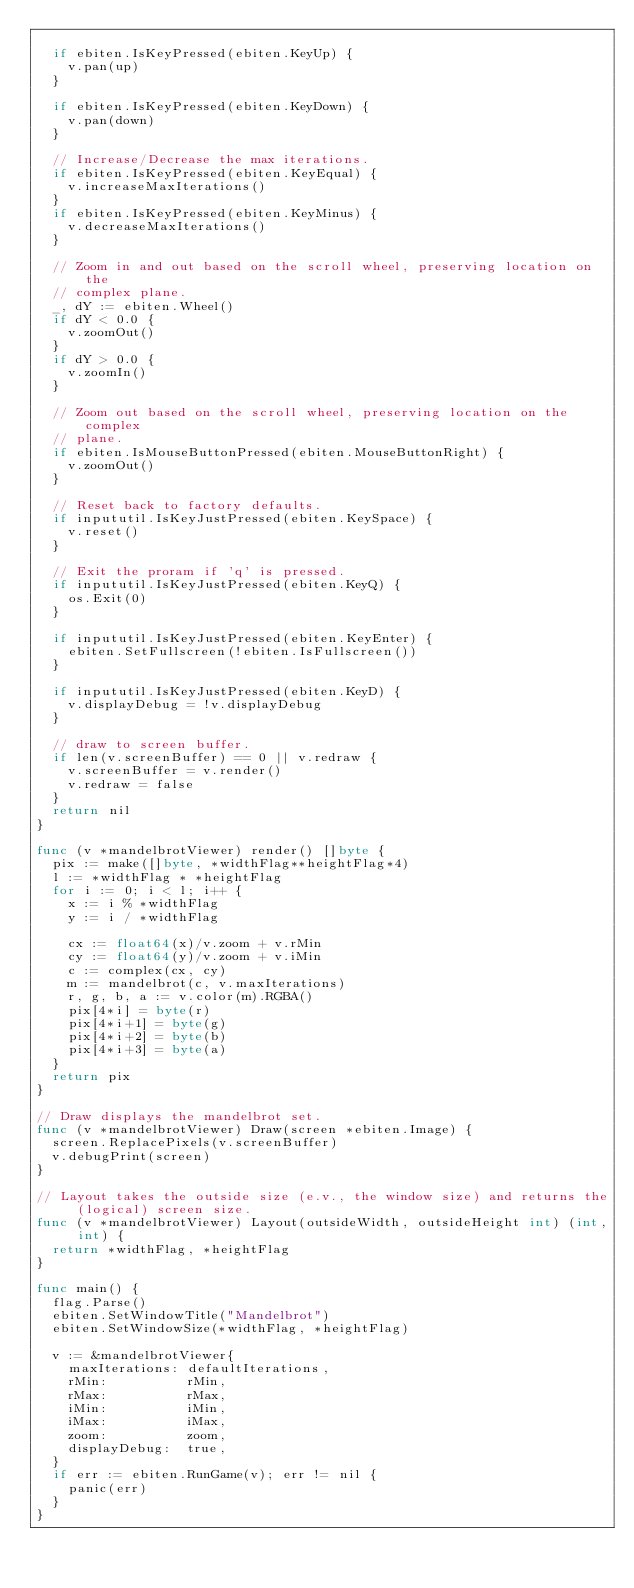Convert code to text. <code><loc_0><loc_0><loc_500><loc_500><_Go_>
	if ebiten.IsKeyPressed(ebiten.KeyUp) {
		v.pan(up)
	}

	if ebiten.IsKeyPressed(ebiten.KeyDown) {
		v.pan(down)
	}

	// Increase/Decrease the max iterations.
	if ebiten.IsKeyPressed(ebiten.KeyEqual) {
		v.increaseMaxIterations()
	}
	if ebiten.IsKeyPressed(ebiten.KeyMinus) {
		v.decreaseMaxIterations()
	}

	// Zoom in and out based on the scroll wheel, preserving location on the
	// complex plane.
	_, dY := ebiten.Wheel()
	if dY < 0.0 {
		v.zoomOut()
	}
	if dY > 0.0 {
		v.zoomIn()
	}

	// Zoom out based on the scroll wheel, preserving location on the complex
	// plane.
	if ebiten.IsMouseButtonPressed(ebiten.MouseButtonRight) {
		v.zoomOut()
	}

	// Reset back to factory defaults.
	if inpututil.IsKeyJustPressed(ebiten.KeySpace) {
		v.reset()
	}

	// Exit the proram if 'q' is pressed.
	if inpututil.IsKeyJustPressed(ebiten.KeyQ) {
		os.Exit(0)
	}

	if inpututil.IsKeyJustPressed(ebiten.KeyEnter) {
		ebiten.SetFullscreen(!ebiten.IsFullscreen())
	}

	if inpututil.IsKeyJustPressed(ebiten.KeyD) {
		v.displayDebug = !v.displayDebug
	}

	// draw to screen buffer.
	if len(v.screenBuffer) == 0 || v.redraw {
		v.screenBuffer = v.render()
		v.redraw = false
	}
	return nil
}

func (v *mandelbrotViewer) render() []byte {
	pix := make([]byte, *widthFlag**heightFlag*4)
	l := *widthFlag * *heightFlag
	for i := 0; i < l; i++ {
		x := i % *widthFlag
		y := i / *widthFlag

		cx := float64(x)/v.zoom + v.rMin
		cy := float64(y)/v.zoom + v.iMin
		c := complex(cx, cy)
		m := mandelbrot(c, v.maxIterations)
		r, g, b, a := v.color(m).RGBA()
		pix[4*i] = byte(r)
		pix[4*i+1] = byte(g)
		pix[4*i+2] = byte(b)
		pix[4*i+3] = byte(a)
	}
	return pix
}

// Draw displays the mandelbrot set.
func (v *mandelbrotViewer) Draw(screen *ebiten.Image) {
	screen.ReplacePixels(v.screenBuffer)
	v.debugPrint(screen)
}

// Layout takes the outside size (e.v., the window size) and returns the (logical) screen size.
func (v *mandelbrotViewer) Layout(outsideWidth, outsideHeight int) (int, int) {
	return *widthFlag, *heightFlag
}

func main() {
	flag.Parse()
	ebiten.SetWindowTitle("Mandelbrot")
	ebiten.SetWindowSize(*widthFlag, *heightFlag)

	v := &mandelbrotViewer{
		maxIterations: defaultIterations,
		rMin:          rMin,
		rMax:          rMax,
		iMin:          iMin,
		iMax:          iMax,
		zoom:          zoom,
		displayDebug:  true,
	}
	if err := ebiten.RunGame(v); err != nil {
		panic(err)
	}
}
</code> 